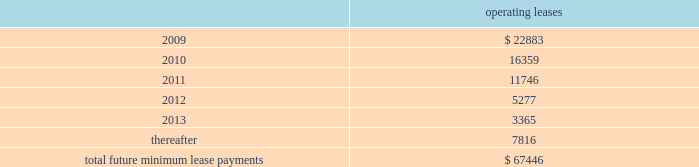Notes to consolidated financial statements 2014 ( continued ) note 12 2014related party transactions in the course of settling money transfer transactions , we purchase foreign currency from consultoria internacional casa de cambio ( 201ccisa 201d ) , a mexican company partially owned by certain of our employees .
As of march 31 , 2008 , mr .
Ra fal lim f3n cortes , a 10% ( 10 % ) shareholder of cisa , was no longer an employee , and we no longer considered cisa a related party .
We purchased 6.1 billion mexican pesos for $ 560.3 million during the ten months ended march 31 , 2008 and 8.1 billion mexican pesos for $ 736.0 million during fiscal 2007 from cisa .
We believe these currency transactions were executed at prevailing market exchange rates .
Also from time to time , money transfer transactions are settled at destination facilities owned by cisa .
We incurred related settlement expenses , included in cost of service in the accompanying consolidated statements of income of $ 0.5 million in the ten months ended march 31 , 2008 .
In fiscal 2007 and 2006 , we incurred related settlement expenses , included in cost of service in the accompanying consolidated statements of income of $ 0.7 and $ 0.6 million , respectively .
In the normal course of business , we periodically utilize the services of contractors to provide software development services .
One of our employees , hired in april 2005 , is also an employee , officer , and part owner of a firm that provides such services .
The services provided by this firm primarily relate to software development in connection with our planned next generation front-end processing system in the united states .
During fiscal 2008 , we capitalized fees paid to this firm of $ 0.3 million .
As of may 31 , 2008 and 2007 , capitalized amounts paid to this firm of $ 4.9 million and $ 4.6 million , respectively , were included in property and equipment in the accompanying consolidated balance sheets .
In addition , we expensed amounts paid to this firm of $ 0.3 million , $ 0.1 million and $ 0.5 million in the years ended may 31 , 2008 , 2007 and 2006 , respectively .
Note 13 2014commitments and contingencies leases we conduct a major part of our operations using leased facilities and equipment .
Many of these leases have renewal and purchase options and provide that we pay the cost of property taxes , insurance and maintenance .
Rent expense on all operating leases for fiscal 2008 , 2007 and 2006 was $ 30.4 million , $ 27.1 million , and $ 24.4 million , respectively .
Future minimum lease payments for all noncancelable leases at may 31 , 2008 were as follows : operating leases .
We are party to a number of other claims and lawsuits incidental to our business .
In the opinion of management , the reasonably possible outcome of such matters , individually or in the aggregate , will not have a material adverse impact on our financial position , liquidity or results of operations. .
What is the exchange rate pesos to dollar in 2008? 
Computations: ((6.1 * 1000) / 560.3)
Answer: 10.88702. 